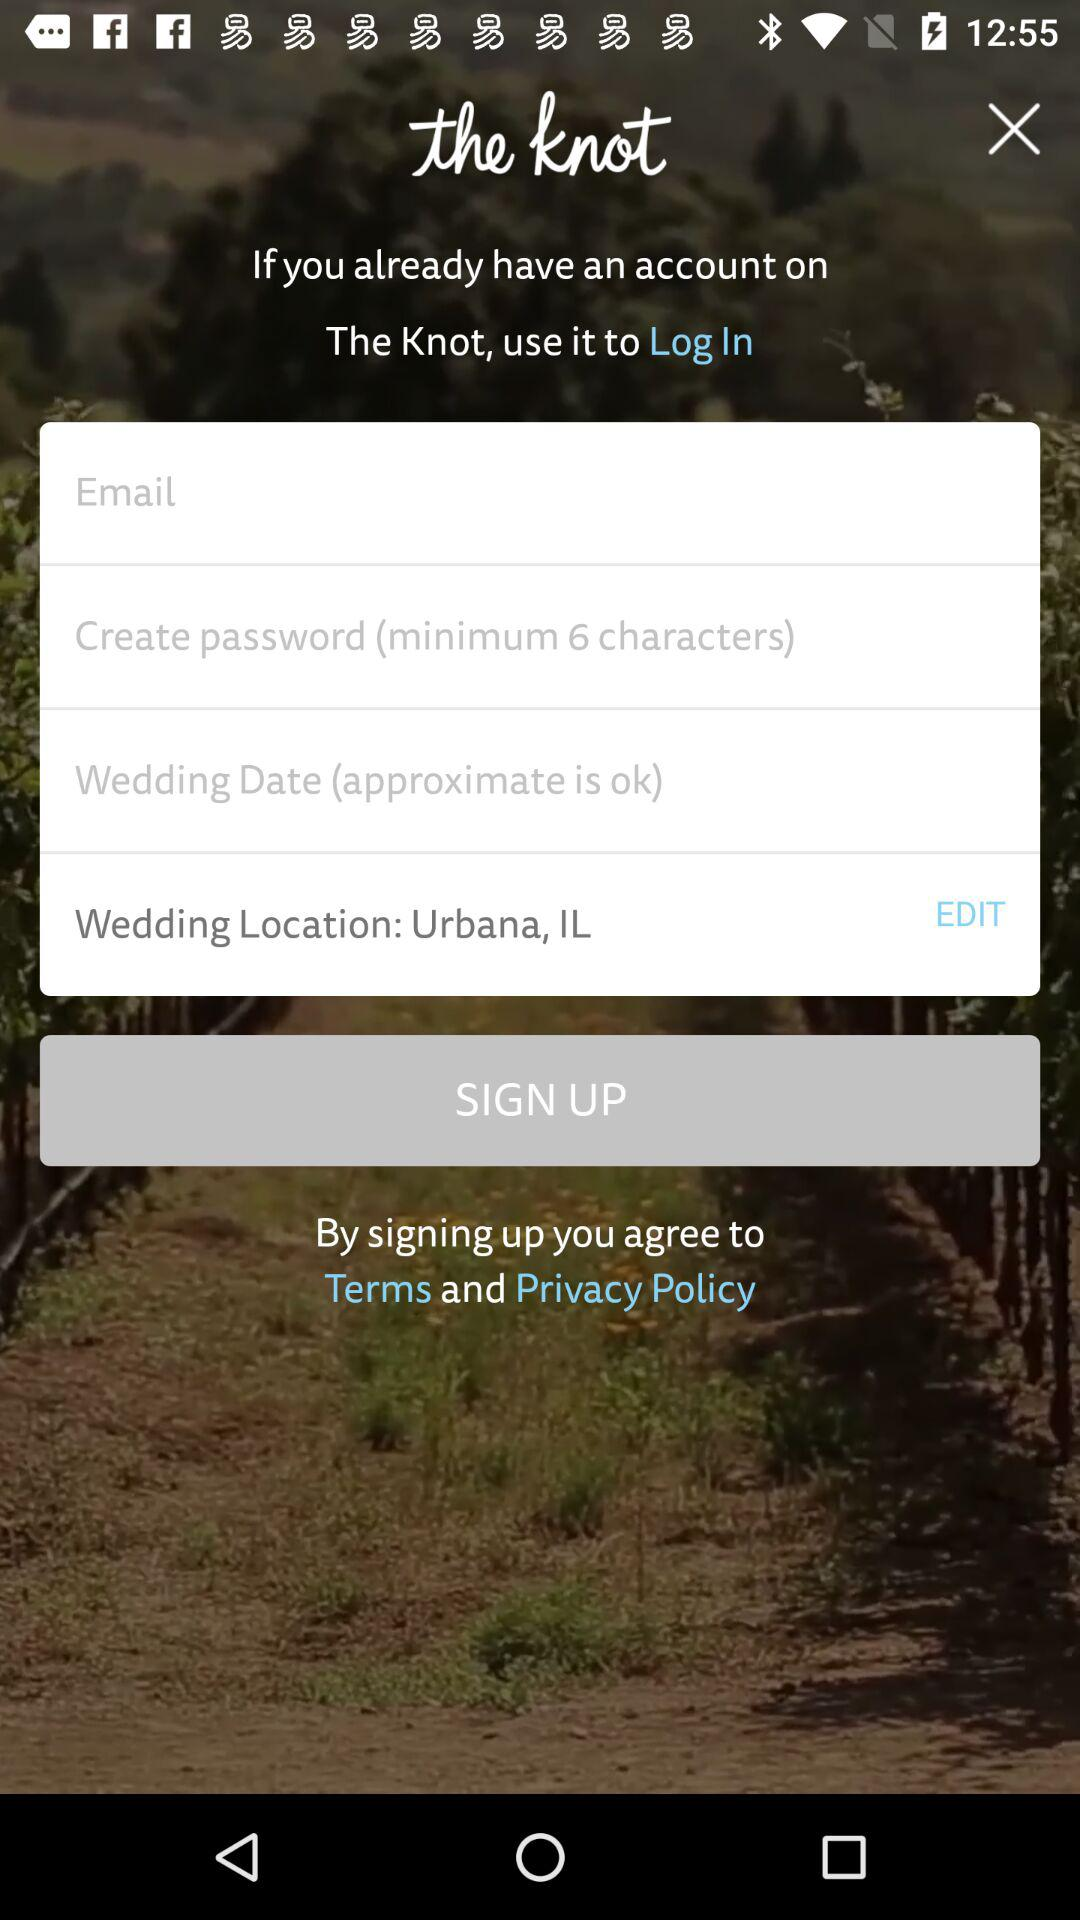What is the name of the application? The name of the application is "the knot". 